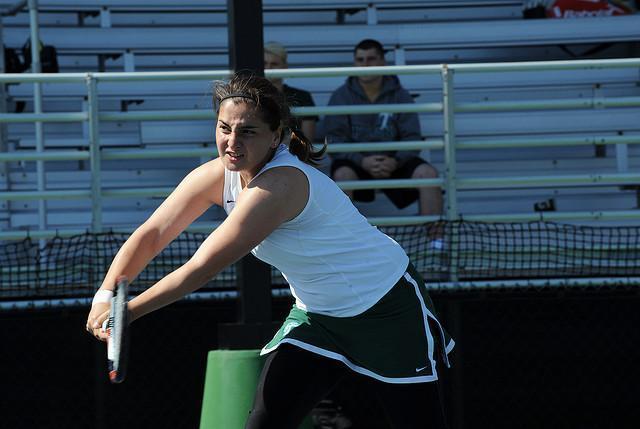How many legs does the woman have?
Give a very brief answer. 2. How many people are in the picture?
Give a very brief answer. 3. How many benches are there?
Give a very brief answer. 2. 